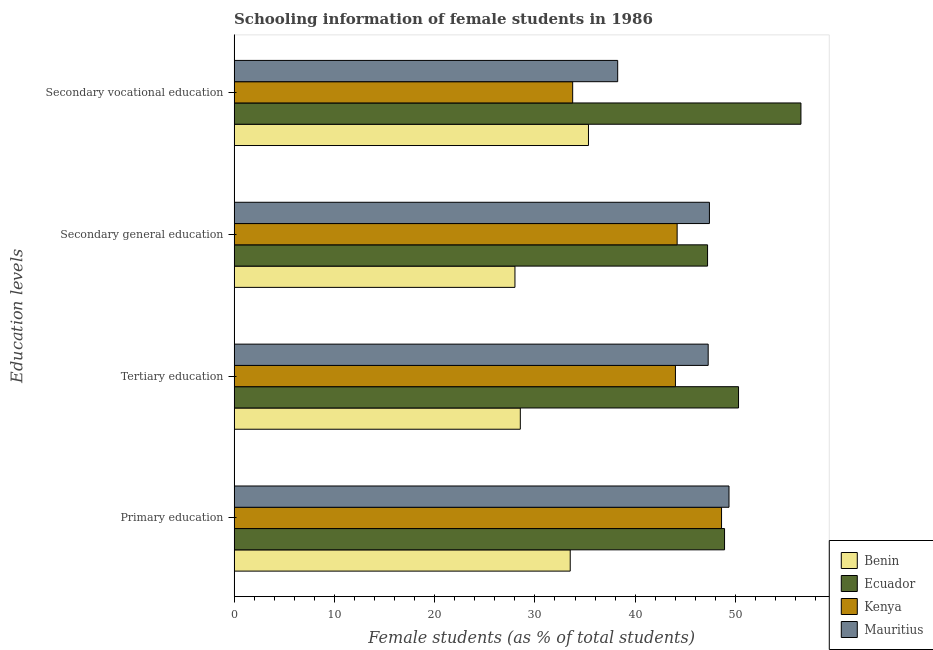How many different coloured bars are there?
Provide a succinct answer. 4. How many bars are there on the 4th tick from the top?
Offer a terse response. 4. How many bars are there on the 2nd tick from the bottom?
Your answer should be very brief. 4. What is the label of the 1st group of bars from the top?
Offer a terse response. Secondary vocational education. What is the percentage of female students in secondary education in Benin?
Provide a succinct answer. 28.01. Across all countries, what is the maximum percentage of female students in secondary education?
Provide a succinct answer. 47.4. Across all countries, what is the minimum percentage of female students in tertiary education?
Provide a short and direct response. 28.54. In which country was the percentage of female students in secondary vocational education maximum?
Your response must be concise. Ecuador. In which country was the percentage of female students in tertiary education minimum?
Provide a succinct answer. Benin. What is the total percentage of female students in secondary vocational education in the graph?
Your answer should be compact. 163.89. What is the difference between the percentage of female students in tertiary education in Ecuador and that in Mauritius?
Provide a short and direct response. 3.03. What is the difference between the percentage of female students in secondary vocational education in Ecuador and the percentage of female students in secondary education in Mauritius?
Give a very brief answer. 9.13. What is the average percentage of female students in secondary vocational education per country?
Provide a succinct answer. 40.97. What is the difference between the percentage of female students in tertiary education and percentage of female students in secondary education in Ecuador?
Your answer should be very brief. 3.09. In how many countries, is the percentage of female students in secondary education greater than 18 %?
Give a very brief answer. 4. What is the ratio of the percentage of female students in primary education in Benin to that in Mauritius?
Offer a very short reply. 0.68. Is the percentage of female students in secondary education in Mauritius less than that in Ecuador?
Offer a very short reply. No. What is the difference between the highest and the second highest percentage of female students in tertiary education?
Offer a terse response. 3.03. What is the difference between the highest and the lowest percentage of female students in tertiary education?
Make the answer very short. 21.76. In how many countries, is the percentage of female students in primary education greater than the average percentage of female students in primary education taken over all countries?
Your response must be concise. 3. Is it the case that in every country, the sum of the percentage of female students in primary education and percentage of female students in secondary vocational education is greater than the sum of percentage of female students in secondary education and percentage of female students in tertiary education?
Offer a very short reply. No. What does the 3rd bar from the top in Secondary vocational education represents?
Give a very brief answer. Ecuador. What does the 4th bar from the bottom in Primary education represents?
Give a very brief answer. Mauritius. Is it the case that in every country, the sum of the percentage of female students in primary education and percentage of female students in tertiary education is greater than the percentage of female students in secondary education?
Offer a very short reply. Yes. Does the graph contain any zero values?
Your response must be concise. No. Does the graph contain grids?
Give a very brief answer. No. Where does the legend appear in the graph?
Offer a very short reply. Bottom right. How many legend labels are there?
Make the answer very short. 4. How are the legend labels stacked?
Provide a succinct answer. Vertical. What is the title of the graph?
Provide a short and direct response. Schooling information of female students in 1986. What is the label or title of the X-axis?
Offer a terse response. Female students (as % of total students). What is the label or title of the Y-axis?
Provide a succinct answer. Education levels. What is the Female students (as % of total students) in Benin in Primary education?
Your response must be concise. 33.52. What is the Female students (as % of total students) in Ecuador in Primary education?
Your answer should be very brief. 48.91. What is the Female students (as % of total students) in Kenya in Primary education?
Provide a succinct answer. 48.61. What is the Female students (as % of total students) in Mauritius in Primary education?
Your answer should be very brief. 49.36. What is the Female students (as % of total students) of Benin in Tertiary education?
Offer a very short reply. 28.54. What is the Female students (as % of total students) of Ecuador in Tertiary education?
Your response must be concise. 50.31. What is the Female students (as % of total students) of Kenya in Tertiary education?
Your answer should be compact. 44.01. What is the Female students (as % of total students) in Mauritius in Tertiary education?
Provide a short and direct response. 47.28. What is the Female students (as % of total students) of Benin in Secondary general education?
Offer a terse response. 28.01. What is the Female students (as % of total students) of Ecuador in Secondary general education?
Provide a short and direct response. 47.22. What is the Female students (as % of total students) in Kenya in Secondary general education?
Your response must be concise. 44.18. What is the Female students (as % of total students) in Mauritius in Secondary general education?
Your response must be concise. 47.4. What is the Female students (as % of total students) of Benin in Secondary vocational education?
Keep it short and to the point. 35.34. What is the Female students (as % of total students) in Ecuador in Secondary vocational education?
Keep it short and to the point. 56.53. What is the Female students (as % of total students) in Kenya in Secondary vocational education?
Offer a terse response. 33.76. What is the Female students (as % of total students) of Mauritius in Secondary vocational education?
Make the answer very short. 38.25. Across all Education levels, what is the maximum Female students (as % of total students) of Benin?
Offer a very short reply. 35.34. Across all Education levels, what is the maximum Female students (as % of total students) in Ecuador?
Ensure brevity in your answer.  56.53. Across all Education levels, what is the maximum Female students (as % of total students) in Kenya?
Your response must be concise. 48.61. Across all Education levels, what is the maximum Female students (as % of total students) in Mauritius?
Offer a terse response. 49.36. Across all Education levels, what is the minimum Female students (as % of total students) of Benin?
Give a very brief answer. 28.01. Across all Education levels, what is the minimum Female students (as % of total students) of Ecuador?
Provide a succinct answer. 47.22. Across all Education levels, what is the minimum Female students (as % of total students) in Kenya?
Provide a succinct answer. 33.76. Across all Education levels, what is the minimum Female students (as % of total students) of Mauritius?
Your response must be concise. 38.25. What is the total Female students (as % of total students) of Benin in the graph?
Give a very brief answer. 125.41. What is the total Female students (as % of total students) of Ecuador in the graph?
Keep it short and to the point. 202.96. What is the total Female students (as % of total students) of Kenya in the graph?
Make the answer very short. 170.57. What is the total Female students (as % of total students) of Mauritius in the graph?
Your response must be concise. 182.29. What is the difference between the Female students (as % of total students) in Benin in Primary education and that in Tertiary education?
Your response must be concise. 4.98. What is the difference between the Female students (as % of total students) in Ecuador in Primary education and that in Tertiary education?
Your answer should be compact. -1.39. What is the difference between the Female students (as % of total students) of Kenya in Primary education and that in Tertiary education?
Give a very brief answer. 4.6. What is the difference between the Female students (as % of total students) of Mauritius in Primary education and that in Tertiary education?
Offer a very short reply. 2.08. What is the difference between the Female students (as % of total students) in Benin in Primary education and that in Secondary general education?
Provide a succinct answer. 5.51. What is the difference between the Female students (as % of total students) of Ecuador in Primary education and that in Secondary general education?
Offer a very short reply. 1.69. What is the difference between the Female students (as % of total students) of Kenya in Primary education and that in Secondary general education?
Offer a very short reply. 4.43. What is the difference between the Female students (as % of total students) in Mauritius in Primary education and that in Secondary general education?
Offer a terse response. 1.95. What is the difference between the Female students (as % of total students) in Benin in Primary education and that in Secondary vocational education?
Ensure brevity in your answer.  -1.82. What is the difference between the Female students (as % of total students) of Ecuador in Primary education and that in Secondary vocational education?
Your response must be concise. -7.62. What is the difference between the Female students (as % of total students) in Kenya in Primary education and that in Secondary vocational education?
Your response must be concise. 14.85. What is the difference between the Female students (as % of total students) of Mauritius in Primary education and that in Secondary vocational education?
Your answer should be very brief. 11.1. What is the difference between the Female students (as % of total students) of Benin in Tertiary education and that in Secondary general education?
Your answer should be compact. 0.54. What is the difference between the Female students (as % of total students) of Ecuador in Tertiary education and that in Secondary general education?
Keep it short and to the point. 3.09. What is the difference between the Female students (as % of total students) in Kenya in Tertiary education and that in Secondary general education?
Make the answer very short. -0.17. What is the difference between the Female students (as % of total students) in Mauritius in Tertiary education and that in Secondary general education?
Provide a short and direct response. -0.12. What is the difference between the Female students (as % of total students) in Benin in Tertiary education and that in Secondary vocational education?
Give a very brief answer. -6.8. What is the difference between the Female students (as % of total students) of Ecuador in Tertiary education and that in Secondary vocational education?
Ensure brevity in your answer.  -6.22. What is the difference between the Female students (as % of total students) of Kenya in Tertiary education and that in Secondary vocational education?
Offer a very short reply. 10.25. What is the difference between the Female students (as % of total students) of Mauritius in Tertiary education and that in Secondary vocational education?
Your response must be concise. 9.03. What is the difference between the Female students (as % of total students) of Benin in Secondary general education and that in Secondary vocational education?
Make the answer very short. -7.33. What is the difference between the Female students (as % of total students) in Ecuador in Secondary general education and that in Secondary vocational education?
Offer a terse response. -9.31. What is the difference between the Female students (as % of total students) of Kenya in Secondary general education and that in Secondary vocational education?
Provide a short and direct response. 10.42. What is the difference between the Female students (as % of total students) of Mauritius in Secondary general education and that in Secondary vocational education?
Your answer should be very brief. 9.15. What is the difference between the Female students (as % of total students) of Benin in Primary education and the Female students (as % of total students) of Ecuador in Tertiary education?
Make the answer very short. -16.79. What is the difference between the Female students (as % of total students) of Benin in Primary education and the Female students (as % of total students) of Kenya in Tertiary education?
Provide a succinct answer. -10.49. What is the difference between the Female students (as % of total students) of Benin in Primary education and the Female students (as % of total students) of Mauritius in Tertiary education?
Offer a terse response. -13.76. What is the difference between the Female students (as % of total students) of Ecuador in Primary education and the Female students (as % of total students) of Kenya in Tertiary education?
Make the answer very short. 4.9. What is the difference between the Female students (as % of total students) of Ecuador in Primary education and the Female students (as % of total students) of Mauritius in Tertiary education?
Keep it short and to the point. 1.63. What is the difference between the Female students (as % of total students) of Kenya in Primary education and the Female students (as % of total students) of Mauritius in Tertiary education?
Give a very brief answer. 1.33. What is the difference between the Female students (as % of total students) of Benin in Primary education and the Female students (as % of total students) of Ecuador in Secondary general education?
Offer a terse response. -13.7. What is the difference between the Female students (as % of total students) of Benin in Primary education and the Female students (as % of total students) of Kenya in Secondary general education?
Ensure brevity in your answer.  -10.66. What is the difference between the Female students (as % of total students) in Benin in Primary education and the Female students (as % of total students) in Mauritius in Secondary general education?
Offer a very short reply. -13.88. What is the difference between the Female students (as % of total students) in Ecuador in Primary education and the Female students (as % of total students) in Kenya in Secondary general education?
Provide a short and direct response. 4.73. What is the difference between the Female students (as % of total students) of Ecuador in Primary education and the Female students (as % of total students) of Mauritius in Secondary general education?
Keep it short and to the point. 1.51. What is the difference between the Female students (as % of total students) in Kenya in Primary education and the Female students (as % of total students) in Mauritius in Secondary general education?
Your answer should be compact. 1.21. What is the difference between the Female students (as % of total students) of Benin in Primary education and the Female students (as % of total students) of Ecuador in Secondary vocational education?
Offer a terse response. -23.01. What is the difference between the Female students (as % of total students) in Benin in Primary education and the Female students (as % of total students) in Kenya in Secondary vocational education?
Your answer should be compact. -0.24. What is the difference between the Female students (as % of total students) in Benin in Primary education and the Female students (as % of total students) in Mauritius in Secondary vocational education?
Your answer should be very brief. -4.73. What is the difference between the Female students (as % of total students) of Ecuador in Primary education and the Female students (as % of total students) of Kenya in Secondary vocational education?
Your answer should be compact. 15.15. What is the difference between the Female students (as % of total students) in Ecuador in Primary education and the Female students (as % of total students) in Mauritius in Secondary vocational education?
Your answer should be very brief. 10.66. What is the difference between the Female students (as % of total students) of Kenya in Primary education and the Female students (as % of total students) of Mauritius in Secondary vocational education?
Offer a terse response. 10.36. What is the difference between the Female students (as % of total students) in Benin in Tertiary education and the Female students (as % of total students) in Ecuador in Secondary general education?
Your answer should be very brief. -18.67. What is the difference between the Female students (as % of total students) in Benin in Tertiary education and the Female students (as % of total students) in Kenya in Secondary general education?
Provide a succinct answer. -15.64. What is the difference between the Female students (as % of total students) of Benin in Tertiary education and the Female students (as % of total students) of Mauritius in Secondary general education?
Your answer should be compact. -18.86. What is the difference between the Female students (as % of total students) in Ecuador in Tertiary education and the Female students (as % of total students) in Kenya in Secondary general education?
Give a very brief answer. 6.12. What is the difference between the Female students (as % of total students) of Ecuador in Tertiary education and the Female students (as % of total students) of Mauritius in Secondary general education?
Ensure brevity in your answer.  2.9. What is the difference between the Female students (as % of total students) of Kenya in Tertiary education and the Female students (as % of total students) of Mauritius in Secondary general education?
Your answer should be compact. -3.39. What is the difference between the Female students (as % of total students) of Benin in Tertiary education and the Female students (as % of total students) of Ecuador in Secondary vocational education?
Your answer should be very brief. -27.99. What is the difference between the Female students (as % of total students) of Benin in Tertiary education and the Female students (as % of total students) of Kenya in Secondary vocational education?
Provide a succinct answer. -5.22. What is the difference between the Female students (as % of total students) in Benin in Tertiary education and the Female students (as % of total students) in Mauritius in Secondary vocational education?
Keep it short and to the point. -9.71. What is the difference between the Female students (as % of total students) in Ecuador in Tertiary education and the Female students (as % of total students) in Kenya in Secondary vocational education?
Your answer should be very brief. 16.54. What is the difference between the Female students (as % of total students) in Ecuador in Tertiary education and the Female students (as % of total students) in Mauritius in Secondary vocational education?
Offer a very short reply. 12.05. What is the difference between the Female students (as % of total students) in Kenya in Tertiary education and the Female students (as % of total students) in Mauritius in Secondary vocational education?
Your answer should be compact. 5.76. What is the difference between the Female students (as % of total students) of Benin in Secondary general education and the Female students (as % of total students) of Ecuador in Secondary vocational education?
Provide a short and direct response. -28.52. What is the difference between the Female students (as % of total students) of Benin in Secondary general education and the Female students (as % of total students) of Kenya in Secondary vocational education?
Give a very brief answer. -5.76. What is the difference between the Female students (as % of total students) in Benin in Secondary general education and the Female students (as % of total students) in Mauritius in Secondary vocational education?
Provide a succinct answer. -10.25. What is the difference between the Female students (as % of total students) of Ecuador in Secondary general education and the Female students (as % of total students) of Kenya in Secondary vocational education?
Your answer should be very brief. 13.45. What is the difference between the Female students (as % of total students) in Ecuador in Secondary general education and the Female students (as % of total students) in Mauritius in Secondary vocational education?
Provide a succinct answer. 8.96. What is the difference between the Female students (as % of total students) of Kenya in Secondary general education and the Female students (as % of total students) of Mauritius in Secondary vocational education?
Your answer should be very brief. 5.93. What is the average Female students (as % of total students) in Benin per Education levels?
Offer a terse response. 31.35. What is the average Female students (as % of total students) of Ecuador per Education levels?
Offer a terse response. 50.74. What is the average Female students (as % of total students) in Kenya per Education levels?
Give a very brief answer. 42.64. What is the average Female students (as % of total students) of Mauritius per Education levels?
Your answer should be very brief. 45.57. What is the difference between the Female students (as % of total students) in Benin and Female students (as % of total students) in Ecuador in Primary education?
Your answer should be compact. -15.39. What is the difference between the Female students (as % of total students) in Benin and Female students (as % of total students) in Kenya in Primary education?
Provide a short and direct response. -15.09. What is the difference between the Female students (as % of total students) of Benin and Female students (as % of total students) of Mauritius in Primary education?
Offer a terse response. -15.84. What is the difference between the Female students (as % of total students) in Ecuador and Female students (as % of total students) in Kenya in Primary education?
Your answer should be compact. 0.3. What is the difference between the Female students (as % of total students) of Ecuador and Female students (as % of total students) of Mauritius in Primary education?
Ensure brevity in your answer.  -0.44. What is the difference between the Female students (as % of total students) of Kenya and Female students (as % of total students) of Mauritius in Primary education?
Provide a short and direct response. -0.74. What is the difference between the Female students (as % of total students) of Benin and Female students (as % of total students) of Ecuador in Tertiary education?
Offer a terse response. -21.76. What is the difference between the Female students (as % of total students) of Benin and Female students (as % of total students) of Kenya in Tertiary education?
Offer a very short reply. -15.47. What is the difference between the Female students (as % of total students) of Benin and Female students (as % of total students) of Mauritius in Tertiary education?
Give a very brief answer. -18.74. What is the difference between the Female students (as % of total students) of Ecuador and Female students (as % of total students) of Kenya in Tertiary education?
Keep it short and to the point. 6.29. What is the difference between the Female students (as % of total students) of Ecuador and Female students (as % of total students) of Mauritius in Tertiary education?
Your response must be concise. 3.03. What is the difference between the Female students (as % of total students) in Kenya and Female students (as % of total students) in Mauritius in Tertiary education?
Offer a very short reply. -3.26. What is the difference between the Female students (as % of total students) in Benin and Female students (as % of total students) in Ecuador in Secondary general education?
Your answer should be very brief. -19.21. What is the difference between the Female students (as % of total students) in Benin and Female students (as % of total students) in Kenya in Secondary general education?
Provide a short and direct response. -16.18. What is the difference between the Female students (as % of total students) in Benin and Female students (as % of total students) in Mauritius in Secondary general education?
Your answer should be compact. -19.4. What is the difference between the Female students (as % of total students) in Ecuador and Female students (as % of total students) in Kenya in Secondary general education?
Your response must be concise. 3.03. What is the difference between the Female students (as % of total students) of Ecuador and Female students (as % of total students) of Mauritius in Secondary general education?
Your answer should be compact. -0.19. What is the difference between the Female students (as % of total students) in Kenya and Female students (as % of total students) in Mauritius in Secondary general education?
Provide a succinct answer. -3.22. What is the difference between the Female students (as % of total students) in Benin and Female students (as % of total students) in Ecuador in Secondary vocational education?
Provide a short and direct response. -21.19. What is the difference between the Female students (as % of total students) in Benin and Female students (as % of total students) in Kenya in Secondary vocational education?
Offer a very short reply. 1.58. What is the difference between the Female students (as % of total students) in Benin and Female students (as % of total students) in Mauritius in Secondary vocational education?
Your response must be concise. -2.91. What is the difference between the Female students (as % of total students) of Ecuador and Female students (as % of total students) of Kenya in Secondary vocational education?
Make the answer very short. 22.77. What is the difference between the Female students (as % of total students) in Ecuador and Female students (as % of total students) in Mauritius in Secondary vocational education?
Keep it short and to the point. 18.28. What is the difference between the Female students (as % of total students) in Kenya and Female students (as % of total students) in Mauritius in Secondary vocational education?
Your response must be concise. -4.49. What is the ratio of the Female students (as % of total students) of Benin in Primary education to that in Tertiary education?
Keep it short and to the point. 1.17. What is the ratio of the Female students (as % of total students) of Ecuador in Primary education to that in Tertiary education?
Provide a succinct answer. 0.97. What is the ratio of the Female students (as % of total students) of Kenya in Primary education to that in Tertiary education?
Keep it short and to the point. 1.1. What is the ratio of the Female students (as % of total students) in Mauritius in Primary education to that in Tertiary education?
Provide a succinct answer. 1.04. What is the ratio of the Female students (as % of total students) in Benin in Primary education to that in Secondary general education?
Give a very brief answer. 1.2. What is the ratio of the Female students (as % of total students) in Ecuador in Primary education to that in Secondary general education?
Your response must be concise. 1.04. What is the ratio of the Female students (as % of total students) of Kenya in Primary education to that in Secondary general education?
Keep it short and to the point. 1.1. What is the ratio of the Female students (as % of total students) of Mauritius in Primary education to that in Secondary general education?
Ensure brevity in your answer.  1.04. What is the ratio of the Female students (as % of total students) in Benin in Primary education to that in Secondary vocational education?
Give a very brief answer. 0.95. What is the ratio of the Female students (as % of total students) of Ecuador in Primary education to that in Secondary vocational education?
Offer a terse response. 0.87. What is the ratio of the Female students (as % of total students) in Kenya in Primary education to that in Secondary vocational education?
Offer a very short reply. 1.44. What is the ratio of the Female students (as % of total students) in Mauritius in Primary education to that in Secondary vocational education?
Ensure brevity in your answer.  1.29. What is the ratio of the Female students (as % of total students) of Benin in Tertiary education to that in Secondary general education?
Provide a succinct answer. 1.02. What is the ratio of the Female students (as % of total students) in Ecuador in Tertiary education to that in Secondary general education?
Provide a succinct answer. 1.07. What is the ratio of the Female students (as % of total students) of Kenya in Tertiary education to that in Secondary general education?
Ensure brevity in your answer.  1. What is the ratio of the Female students (as % of total students) in Benin in Tertiary education to that in Secondary vocational education?
Offer a terse response. 0.81. What is the ratio of the Female students (as % of total students) of Ecuador in Tertiary education to that in Secondary vocational education?
Make the answer very short. 0.89. What is the ratio of the Female students (as % of total students) in Kenya in Tertiary education to that in Secondary vocational education?
Offer a terse response. 1.3. What is the ratio of the Female students (as % of total students) in Mauritius in Tertiary education to that in Secondary vocational education?
Your answer should be compact. 1.24. What is the ratio of the Female students (as % of total students) in Benin in Secondary general education to that in Secondary vocational education?
Offer a terse response. 0.79. What is the ratio of the Female students (as % of total students) in Ecuador in Secondary general education to that in Secondary vocational education?
Give a very brief answer. 0.84. What is the ratio of the Female students (as % of total students) of Kenya in Secondary general education to that in Secondary vocational education?
Offer a very short reply. 1.31. What is the ratio of the Female students (as % of total students) of Mauritius in Secondary general education to that in Secondary vocational education?
Keep it short and to the point. 1.24. What is the difference between the highest and the second highest Female students (as % of total students) in Benin?
Your response must be concise. 1.82. What is the difference between the highest and the second highest Female students (as % of total students) in Ecuador?
Provide a short and direct response. 6.22. What is the difference between the highest and the second highest Female students (as % of total students) in Kenya?
Keep it short and to the point. 4.43. What is the difference between the highest and the second highest Female students (as % of total students) in Mauritius?
Offer a very short reply. 1.95. What is the difference between the highest and the lowest Female students (as % of total students) in Benin?
Give a very brief answer. 7.33. What is the difference between the highest and the lowest Female students (as % of total students) of Ecuador?
Your answer should be very brief. 9.31. What is the difference between the highest and the lowest Female students (as % of total students) in Kenya?
Make the answer very short. 14.85. What is the difference between the highest and the lowest Female students (as % of total students) in Mauritius?
Your answer should be very brief. 11.1. 